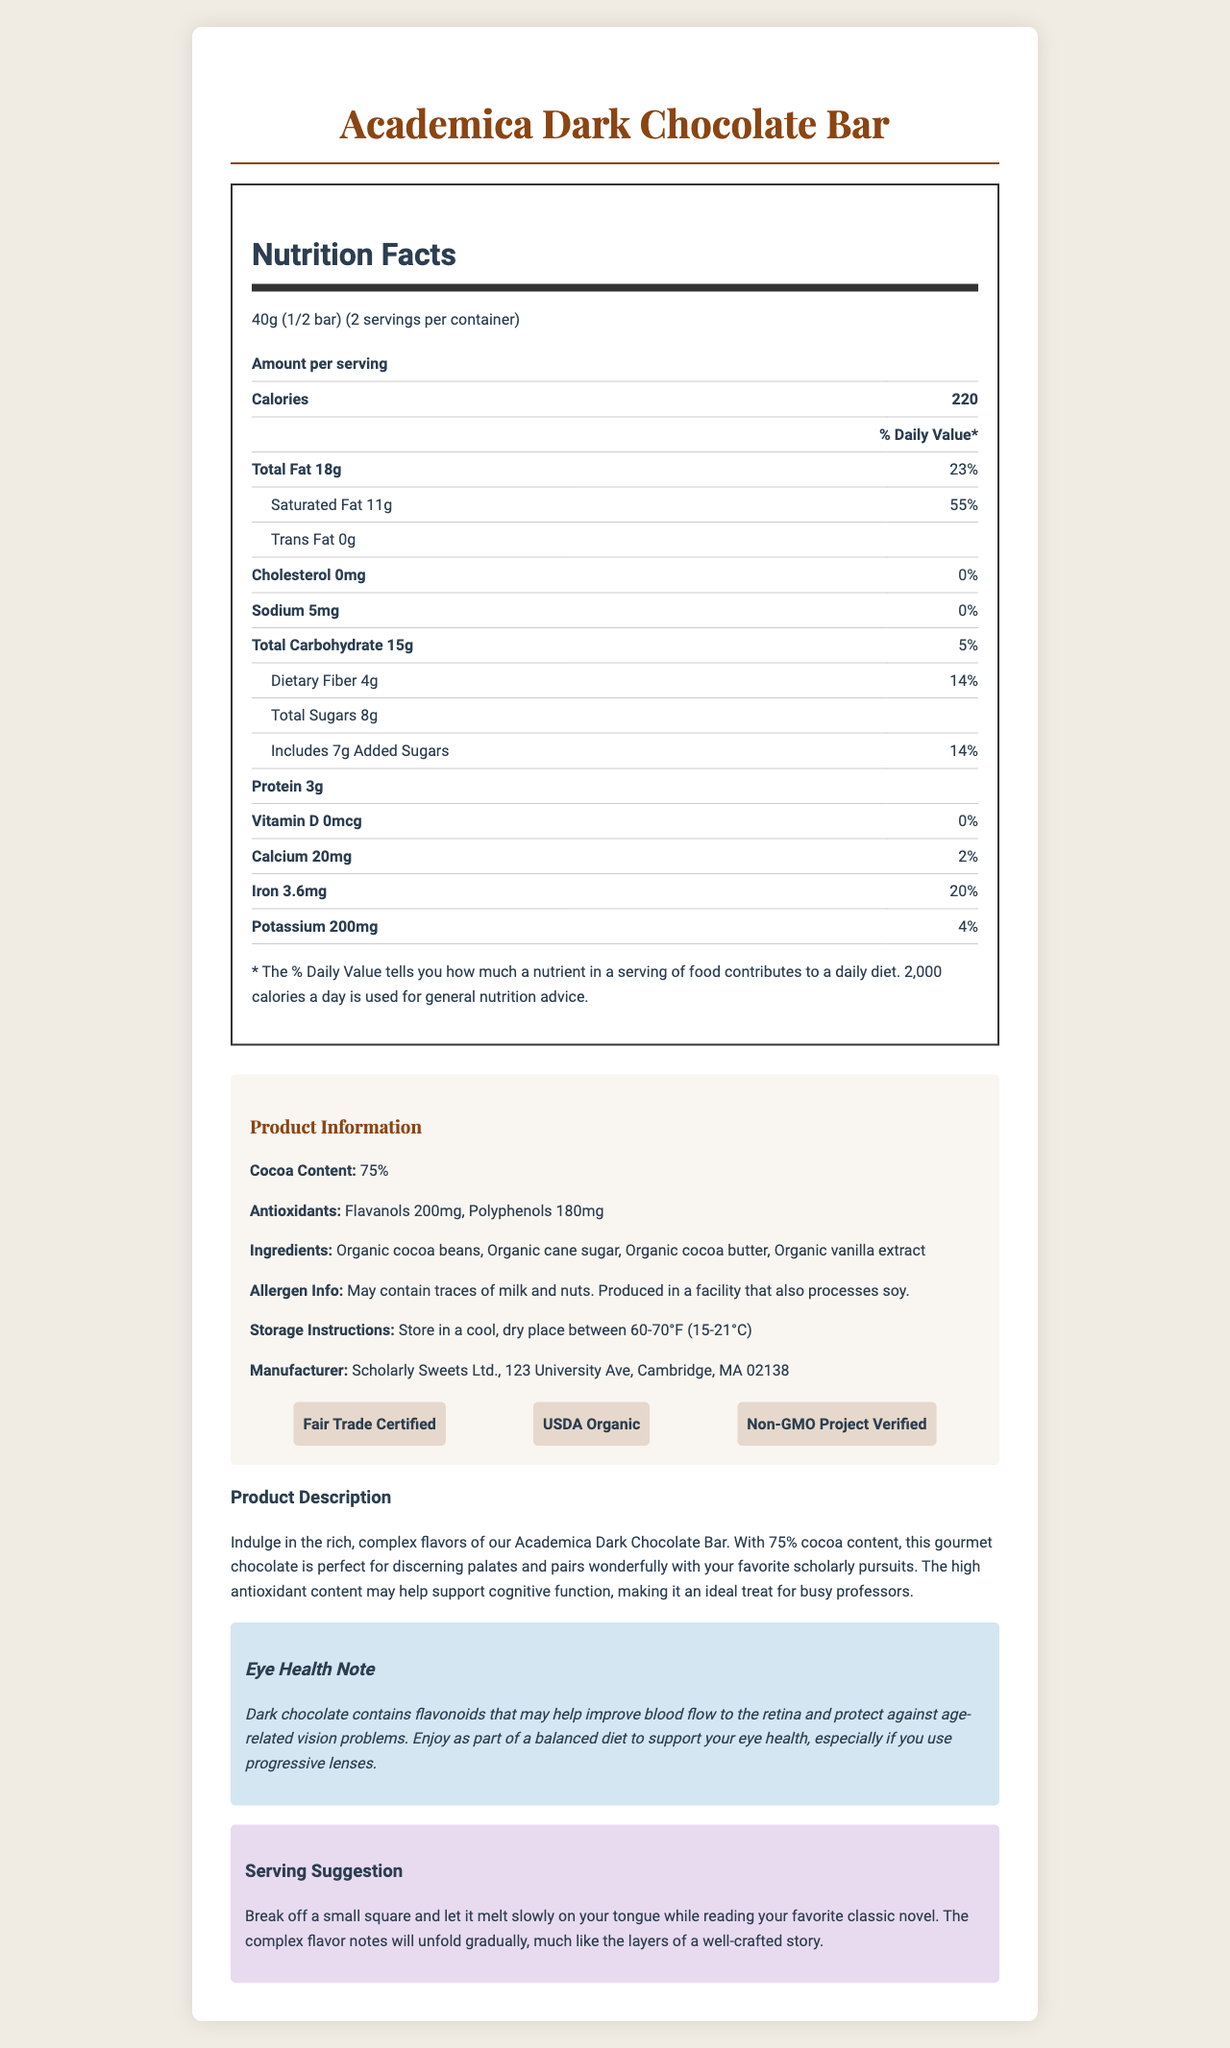what is the serving size of the Academica Dark Chocolate Bar? The serving size is specified in the nutrition facts as "40g (1/2 bar)".
Answer: 40g (1/2 bar) how many calories are there per serving? The document lists "220" calories per serving in the nutrition facts section.
Answer: 220 how much saturated fat does one serving of the chocolate bar contain? The nutrition label clearly states that one serving contains 11g of saturated fat.
Answer: 11g Does the chocolate bar contain any trans fat? The nutrition facts label shows that the amount of trans fat per serving is "0g".
Answer: No What percentage of the daily value of iron does one serving provide? The nutrition label shows that one serving provides 20% of the daily value for iron.
Answer: 20% how much protein is in one serving of the chocolate bar? The nutrition facts label lists that one serving contains 3g of protein.
Answer: 3g which of the following certifications does the chocolate bar have? A. Gluten-Free B. Fair Trade Certified C. Kosher The certifications listed include "Fair Trade Certified," "USDA Organic," and "Non-GMO Project Verified."
Answer: B What is the total carbohydrate content per serving? A. 10g B. 15g C. 20g D. 25g The nutrition facts state that the total carbohydrate content per serving is 15g.
Answer: B Does this chocolate bar contain any added sugars? The label indicates 7g of "added sugars" per serving, contributing to 14% of the daily value.
Answer: Yes Summarize the main idea of the document. The document is well-organized and offers a comprehensive overview of the chocolate bar's nutritional content, ingredients, health benefits, and advice on storage and consumption.
Answer: The document provides detailed information about the Academica Dark Chocolate Bar, including its nutrition facts, ingredients, allergen information, certifications, and additional notes on eye health benefits and serving suggestions. How does the product claim to support cognitive function? The product description states that the high antioxidant content may help support cognitive function.
Answer: Due to its high antioxidant content, including flavanols and polyphenols. What is the recommended storage temperature range for the chocolate bar? The storage instructions specify to keep the chocolate in a cool, dry place between 60-70°F (15-21°C).
Answer: 60-70°F (15-21°C) Does the chocolate bar contain any milk? The allergen information notes that the chocolate bar may contain traces of milk.
Answer: May contain traces of milk Who is the manufacturer of the chocolate bar? The manufacturer's information is listed as Scholarly Sweets Ltd., with a specific address provided.
Answer: Scholarly Sweets Ltd., 123 University Ave, Cambridge, MA 02138 Which ingredient in the chocolate bar is explicitly organic? The ingredients list specifies "Organic cocoa beans" among others.
Answer: Organic cocoa beans What is the sugar content for the entire chocolate bar? There are 8g of total sugars per serving and 2 servings per container, resulting in 16g of sugar for the entire bar.
Answer: 16g How might dark chocolate benefit eye health according to the document? The eye health note mentions that flavonoids could improve retinal blood flow and protect from age-related vision issues.
Answer: Flavonoids in dark chocolate may improve blood flow to the retina and protect against age-related vision problems. What are the total flavanols and polyphenols content per serving? The product information section lists these specific amounts of antioxidants.
Answer: Flavanols: 200mg, Polyphenols: 180mg How much sodium is contained in a whole chocolate bar? One serving contains 5mg of sodium, and since there are 2 servings per container, the whole bar contains a total of 10mg of sodium.
Answer: 10mg Is the chocolate bar certified Gluten-Free? There is no information provided about gluten-free certification in the document.
Answer: Cannot be determined 